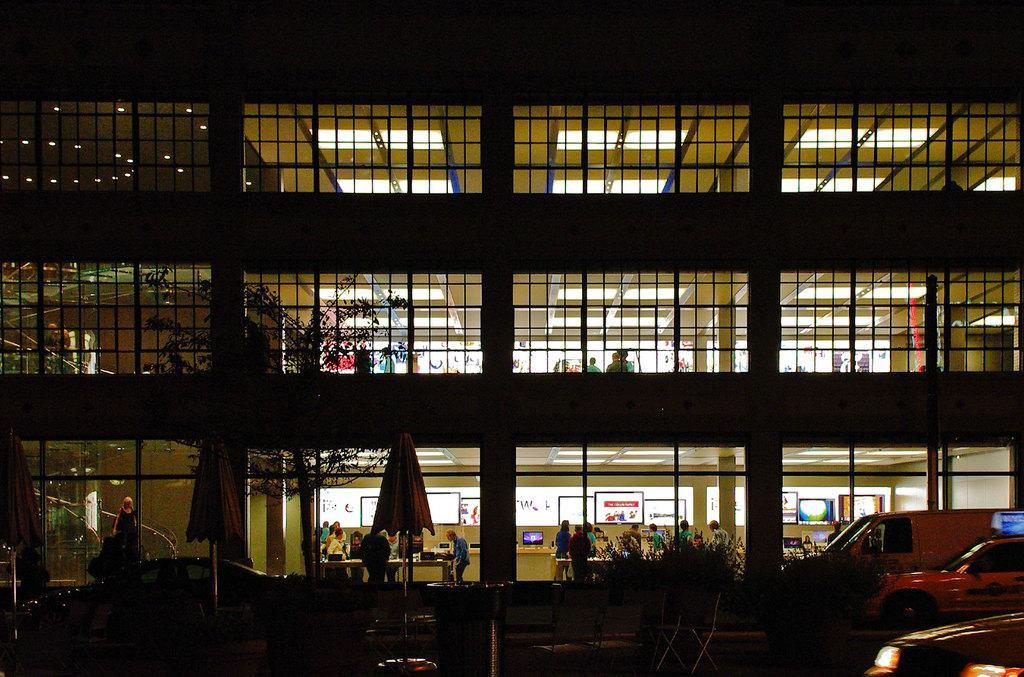In one or two sentences, can you explain what this image depicts? In this image there is a building in middle of this image and there are some are parked at outside to this building. These vehicles are at bottom right corner, and some objects are kept outside to this building, and there is one another car at left side of this image. There is an umbrella at bottom of this image. and there is a tree at left side of this image. 